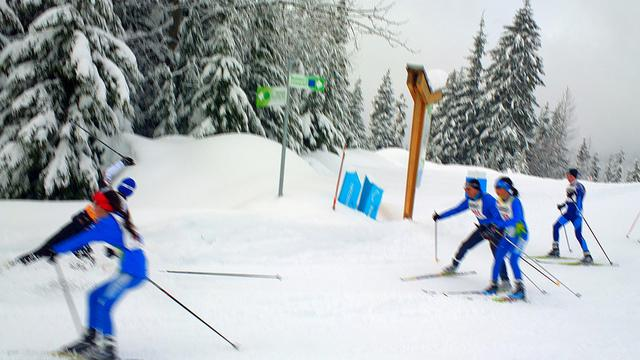What are these people doing with each other? skiing 